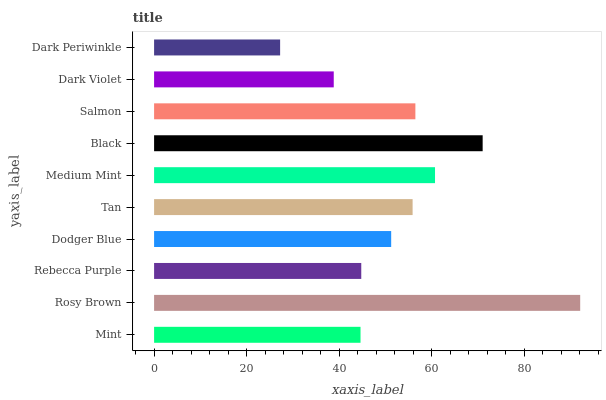Is Dark Periwinkle the minimum?
Answer yes or no. Yes. Is Rosy Brown the maximum?
Answer yes or no. Yes. Is Rebecca Purple the minimum?
Answer yes or no. No. Is Rebecca Purple the maximum?
Answer yes or no. No. Is Rosy Brown greater than Rebecca Purple?
Answer yes or no. Yes. Is Rebecca Purple less than Rosy Brown?
Answer yes or no. Yes. Is Rebecca Purple greater than Rosy Brown?
Answer yes or no. No. Is Rosy Brown less than Rebecca Purple?
Answer yes or no. No. Is Tan the high median?
Answer yes or no. Yes. Is Dodger Blue the low median?
Answer yes or no. Yes. Is Rosy Brown the high median?
Answer yes or no. No. Is Dark Violet the low median?
Answer yes or no. No. 